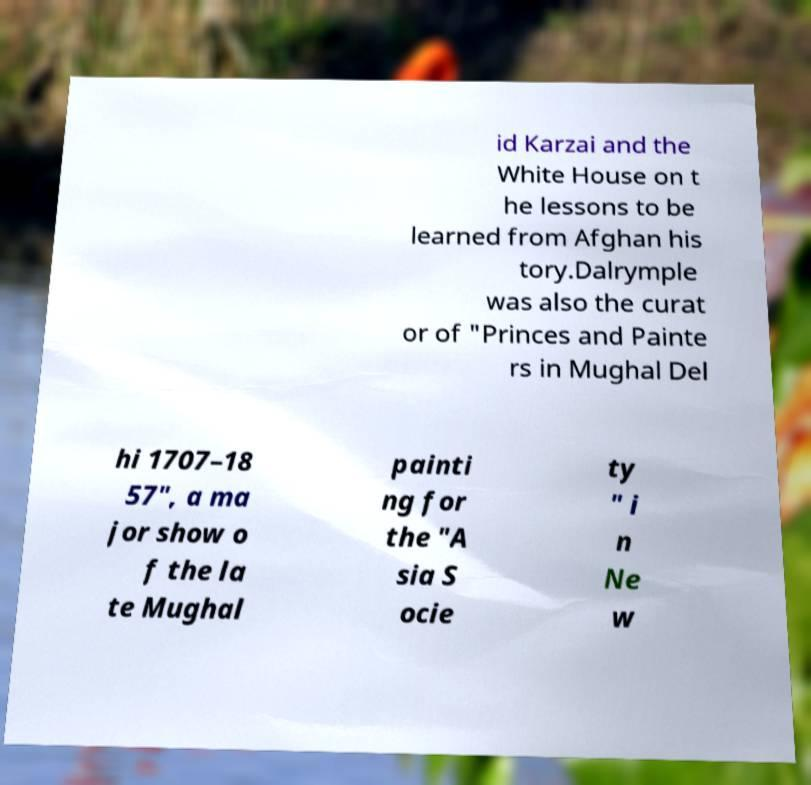I need the written content from this picture converted into text. Can you do that? id Karzai and the White House on t he lessons to be learned from Afghan his tory.Dalrymple was also the curat or of "Princes and Painte rs in Mughal Del hi 1707–18 57", a ma jor show o f the la te Mughal painti ng for the "A sia S ocie ty " i n Ne w 